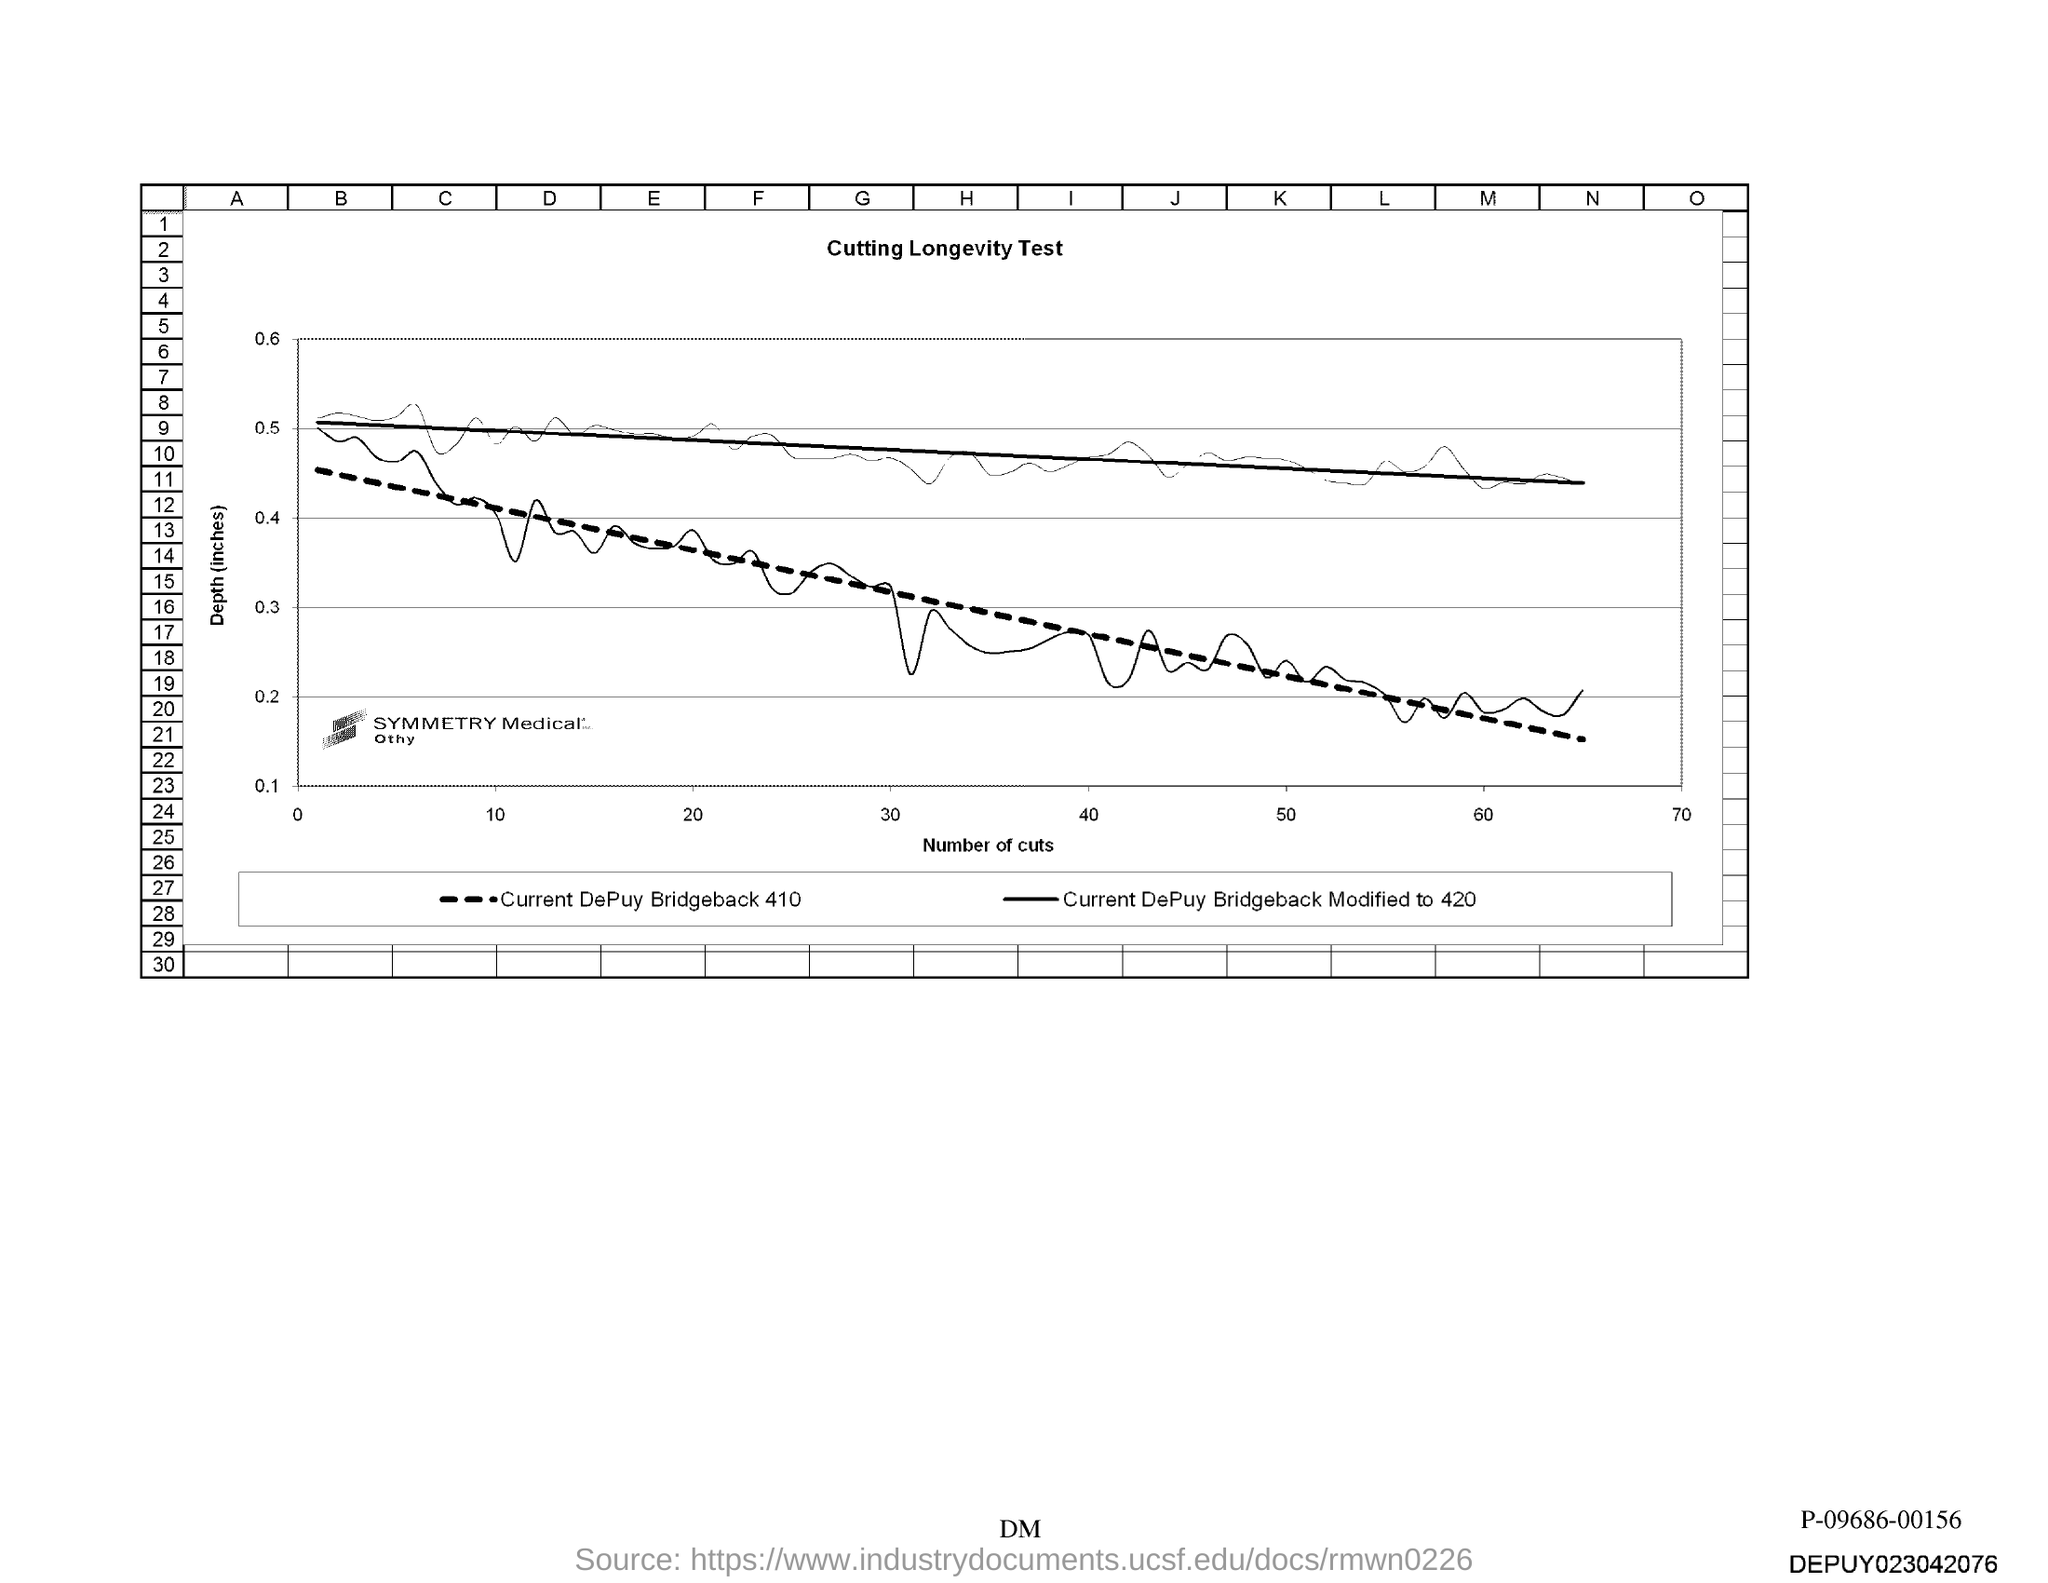List a handful of essential elements in this visual. The x-axis of the graph represents the number of cuts made during the process of separating the seeds of the fruit of the pomegranate. 